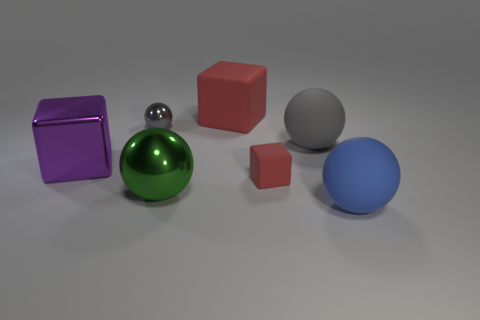Could you describe the lighting in the scene? The lighting in the scene appears to be diffused, with soft shadows indicating the likely presence of a large, distant light source above the objects. This lighting setup would typically be used to reduce harsh shadows and give the scene a calm, even tone. It emphasizes the shapes and textures of the objects without creating too much contrast. 